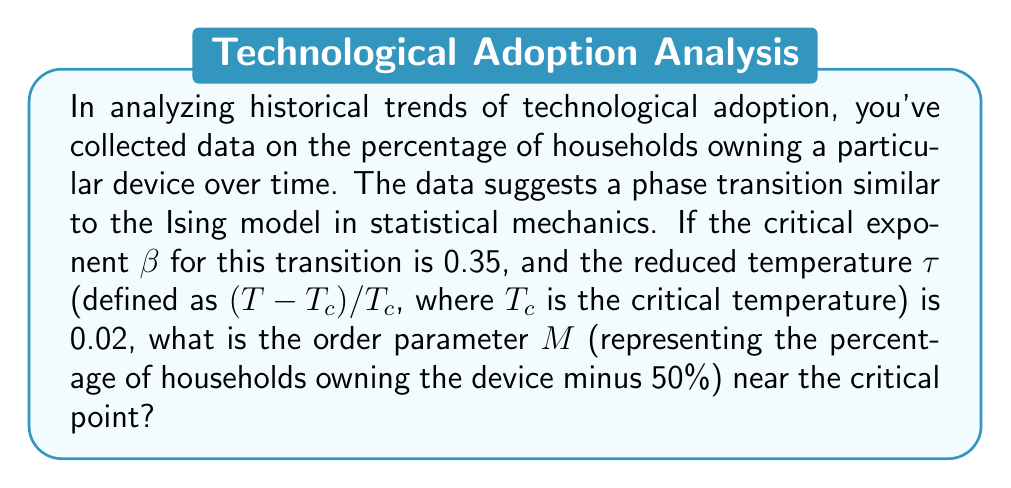Could you help me with this problem? To solve this problem, we'll use concepts from statistical mechanics applied to historical trend analysis:

1) Near a critical point, the order parameter M follows a power law relationship with the reduced temperature τ:

   $$M \propto |\tau|^\beta$$

2) We are given:
   - Critical exponent β = 0.35
   - Reduced temperature τ = 0.02

3) To find the exact value, we need a proportionality constant. In the absence of this, we can express M in terms of a constant A:

   $$M = A|\tau|^\beta$$

4) Substituting the known values:

   $$M = A|0.02|^{0.35}$$

5) Simplifying:

   $$M = A \cdot 0.02^{0.35}$$

6) Calculate 0.02^0.35:

   $$0.02^{0.35} \approx 0.2154$$

7) Therefore, the final expression for M is:

   $$M \approx 0.2154A$$

This means the order parameter M (the percentage of households owning the device minus 50%) is approximately 0.2154 times some constant A near the critical point.
Answer: $$M \approx 0.2154A$$ 